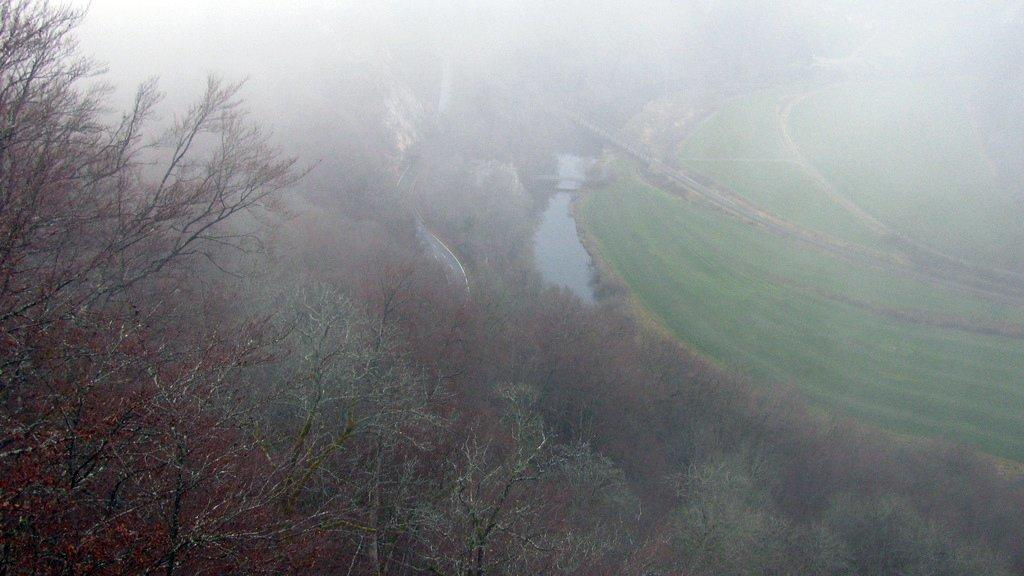What type of vegetation can be seen in the image? There are trees in the image. What natural element is visible in the image? There is water visible in the image. What type of man-made structure is present in the image? There is a road in the image. What type of ground cover is on the right side of the image? There is grass on the right side of the image. What is your sister doing in the image? There is no reference to a sister or any person in the image, so it is not possible to answer that question. 